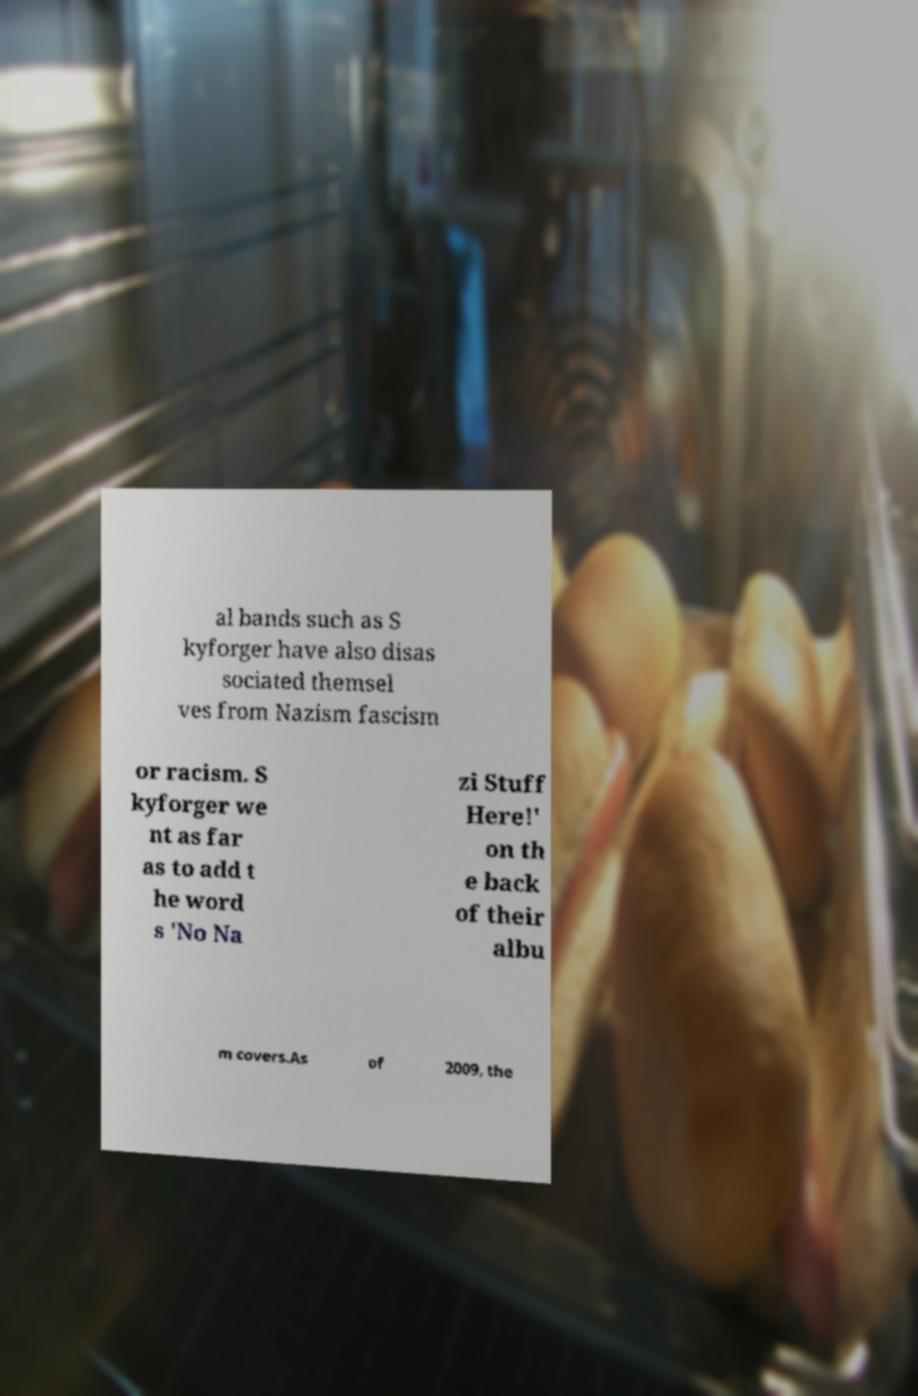What messages or text are displayed in this image? I need them in a readable, typed format. al bands such as S kyforger have also disas sociated themsel ves from Nazism fascism or racism. S kyforger we nt as far as to add t he word s 'No Na zi Stuff Here!' on th e back of their albu m covers.As of 2009, the 